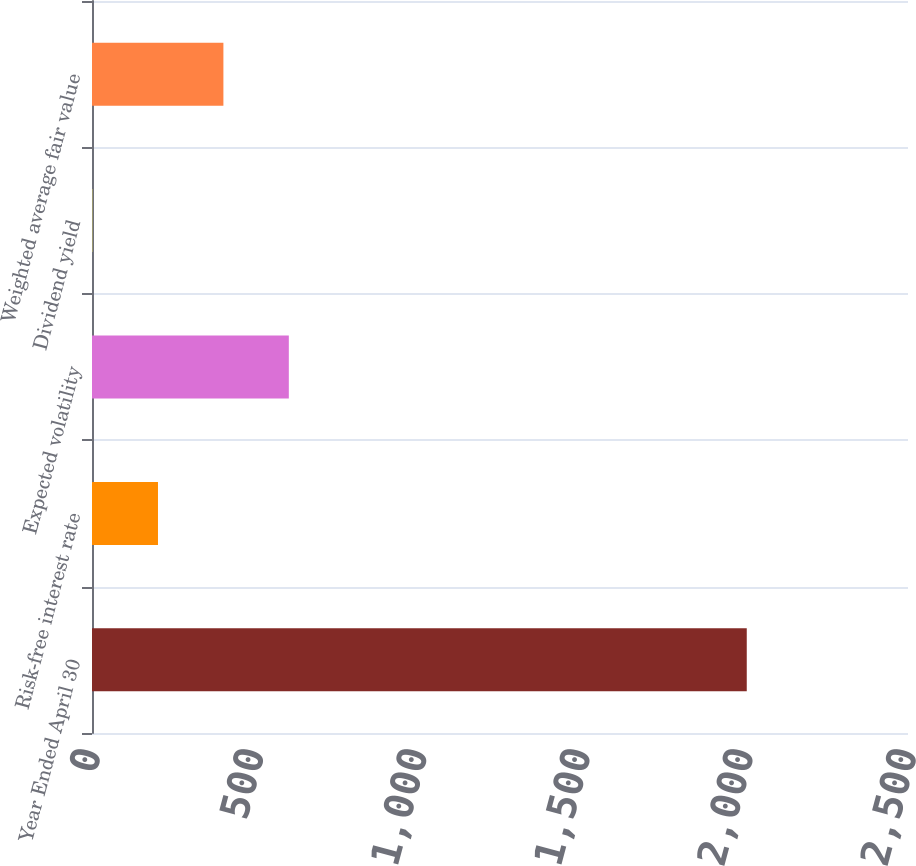Convert chart. <chart><loc_0><loc_0><loc_500><loc_500><bar_chart><fcel>Year Ended April 30<fcel>Risk-free interest rate<fcel>Expected volatility<fcel>Dividend yield<fcel>Weighted average fair value<nl><fcel>2006<fcel>202.15<fcel>603.01<fcel>1.72<fcel>402.58<nl></chart> 